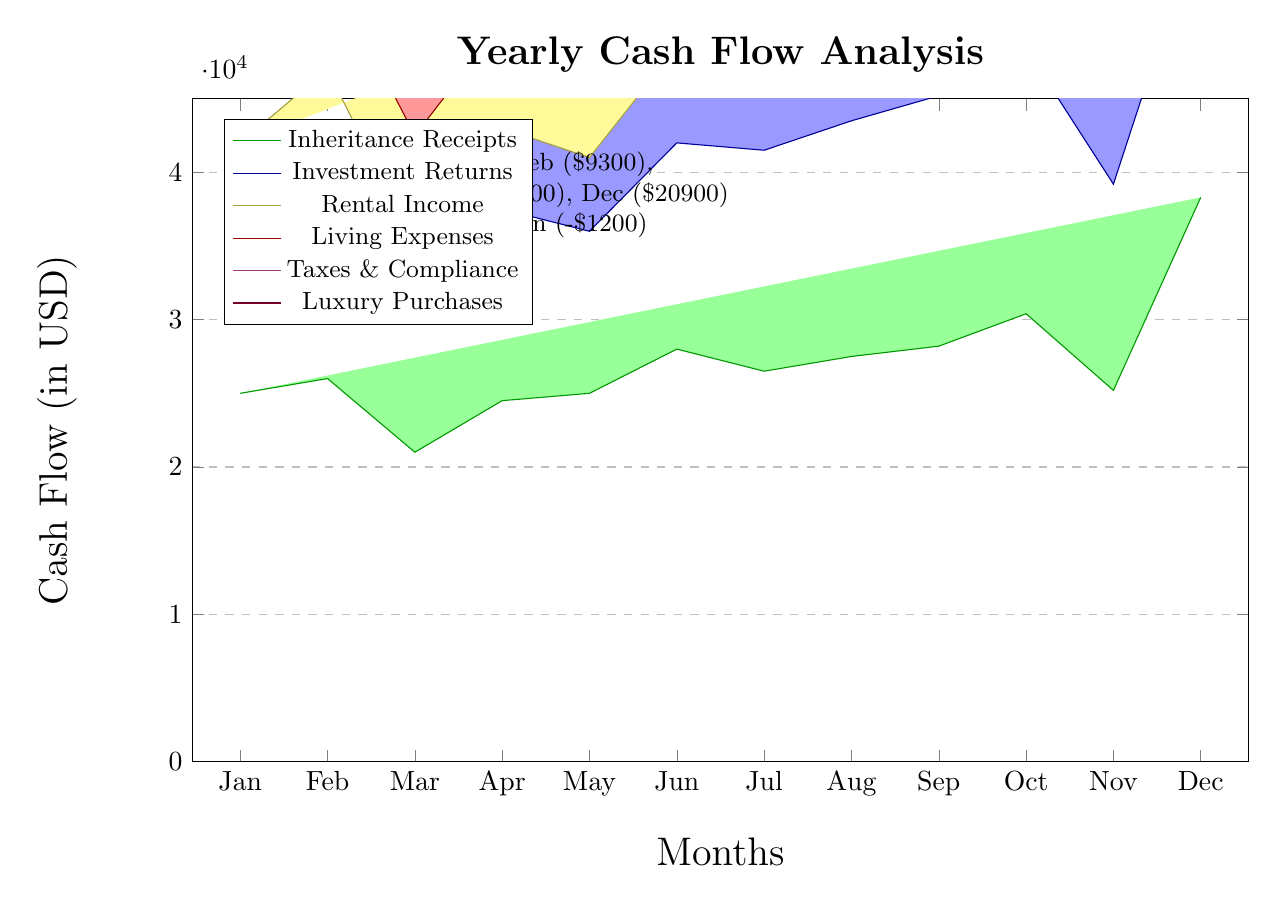What is the total cash inflow for December? The total cash inflow for December is represented by the green bar (inheritance receipts) which is 38,300 USD.
Answer: 38300 Which month had the highest living expenses? The highest living expenses are captured by the red bar, with the month of May showing the peak at 6,800 USD.
Answer: 6800 What was the cash flow surplus for February? To find the surplus in February, we subtract the total cash outflow (sum of other colored bars) from the cash inflow. The inflow is 26,000 USD, while the outflows total 16,700 USD, giving a surplus of 9,300 USD.
Answer: 9300 During which months did the heiress have a deficit? The deficit months are shown specifically in the highlights, which mention March and June as the months where outflows exceeded inflows, leading to deficiencies of 3,500 and 1,200 USD, respectively.
Answer: March, June What is the total cash outflow for the year? The total cash outflow can be calculated by summing up the blue, yellow, red, magenta, and purple areas for all months. This total amounts to 164,000 USD.
Answer: 164000 In which month did the heiress have the largest cash inflow? The largest cash inflow occurs in December, with a value of 38,300 USD as represented in the green bar.
Answer: December Which type of income had the least amount in July? The lowest income in July comes from luxury purchases, displayed in the purple color, amounting to 2,100 USD.
Answer: 2100 How many months had a cash flow surplus? Referring to the highlights, there are five months where a surplus is noted: January, February, April, August, and December.
Answer: 5 What is the cash flow situation for August? In August, the inflow is 27,500 USD and the outflow is 16,900 USD, resulting in a surplus of 10,600 USD.
Answer: Surplus of 10600 